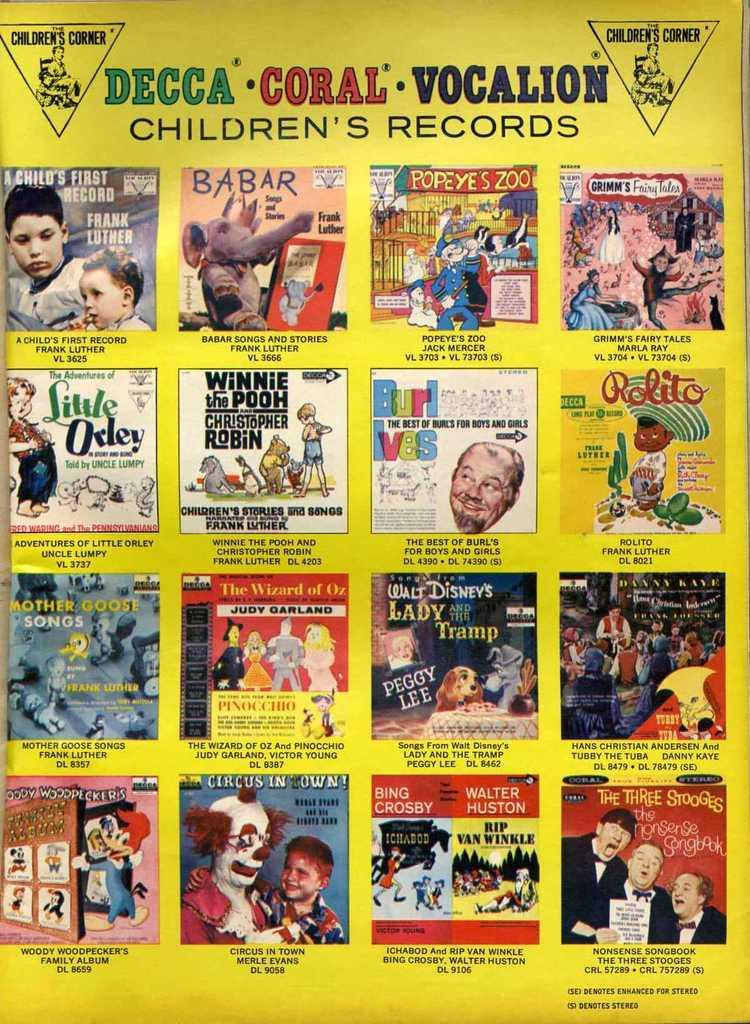What is the color of the poster in the image? The poster is yellow. What type of content is on the poster? The poster contains a collage of images. Are there any words on the poster? Yes, there is text written on the poster. What is the color of the background in the image? The background of the image is yellow. How many knees are visible in the image? There are no knees visible in the image; it features a yellow poster with a collage of images and text. What type of suit is being worn by the person in the image? There is no person wearing a suit present in the image. 